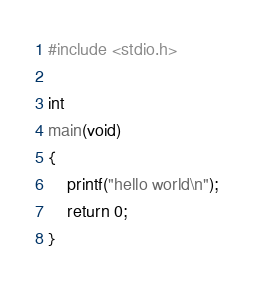<code> <loc_0><loc_0><loc_500><loc_500><_C_>#include <stdio.h>

int
main(void)
{
	printf("hello world\n");
	return 0;
}
</code> 